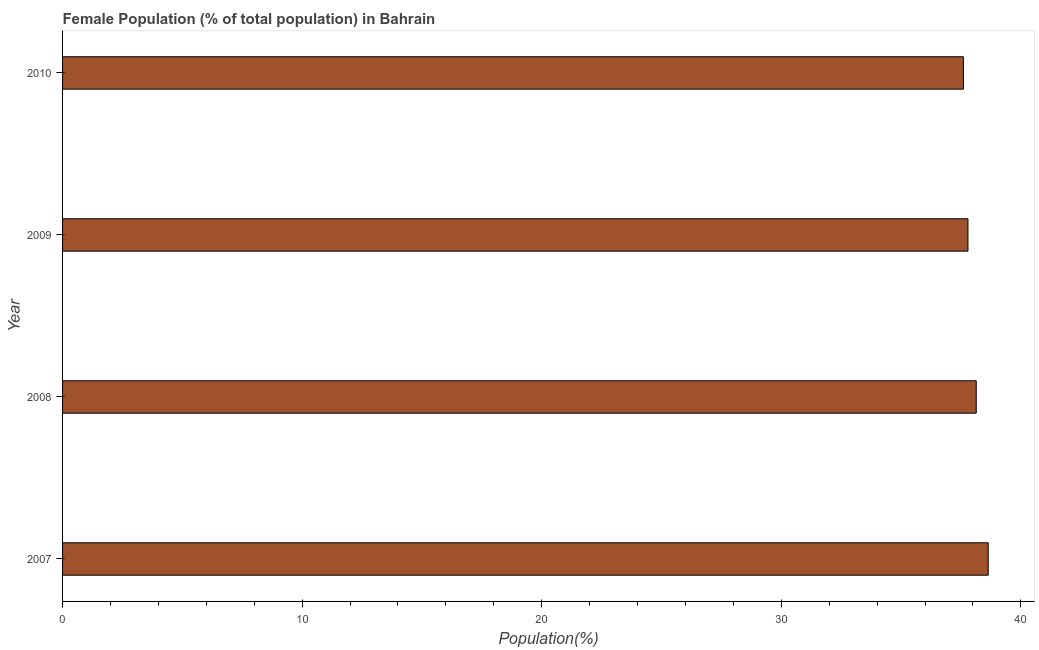Does the graph contain any zero values?
Give a very brief answer. No. Does the graph contain grids?
Offer a terse response. No. What is the title of the graph?
Ensure brevity in your answer.  Female Population (% of total population) in Bahrain. What is the label or title of the X-axis?
Offer a very short reply. Population(%). What is the label or title of the Y-axis?
Give a very brief answer. Year. What is the female population in 2009?
Give a very brief answer. 37.79. Across all years, what is the maximum female population?
Offer a very short reply. 38.64. Across all years, what is the minimum female population?
Your answer should be compact. 37.6. What is the sum of the female population?
Provide a short and direct response. 152.17. What is the difference between the female population in 2009 and 2010?
Provide a succinct answer. 0.19. What is the average female population per year?
Provide a short and direct response. 38.04. What is the median female population?
Your answer should be very brief. 37.96. Is the sum of the female population in 2008 and 2010 greater than the maximum female population across all years?
Ensure brevity in your answer.  Yes. In how many years, is the female population greater than the average female population taken over all years?
Your answer should be compact. 2. How many years are there in the graph?
Offer a terse response. 4. What is the Population(%) of 2007?
Your answer should be very brief. 38.64. What is the Population(%) of 2008?
Offer a very short reply. 38.14. What is the Population(%) of 2009?
Your response must be concise. 37.79. What is the Population(%) of 2010?
Ensure brevity in your answer.  37.6. What is the difference between the Population(%) in 2007 and 2008?
Your response must be concise. 0.5. What is the difference between the Population(%) in 2007 and 2009?
Make the answer very short. 0.85. What is the difference between the Population(%) in 2007 and 2010?
Offer a terse response. 1.04. What is the difference between the Population(%) in 2008 and 2009?
Provide a short and direct response. 0.35. What is the difference between the Population(%) in 2008 and 2010?
Your answer should be very brief. 0.54. What is the difference between the Population(%) in 2009 and 2010?
Your answer should be very brief. 0.19. What is the ratio of the Population(%) in 2007 to that in 2009?
Your answer should be compact. 1.02. What is the ratio of the Population(%) in 2007 to that in 2010?
Your answer should be compact. 1.03. What is the ratio of the Population(%) in 2008 to that in 2009?
Provide a short and direct response. 1.01. What is the ratio of the Population(%) in 2008 to that in 2010?
Offer a terse response. 1.01. 